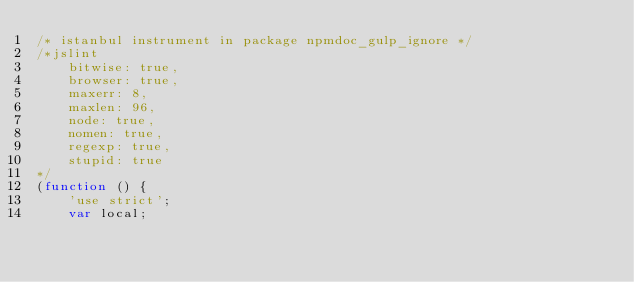<code> <loc_0><loc_0><loc_500><loc_500><_JavaScript_>/* istanbul instrument in package npmdoc_gulp_ignore */
/*jslint
    bitwise: true,
    browser: true,
    maxerr: 8,
    maxlen: 96,
    node: true,
    nomen: true,
    regexp: true,
    stupid: true
*/
(function () {
    'use strict';
    var local;


</code> 